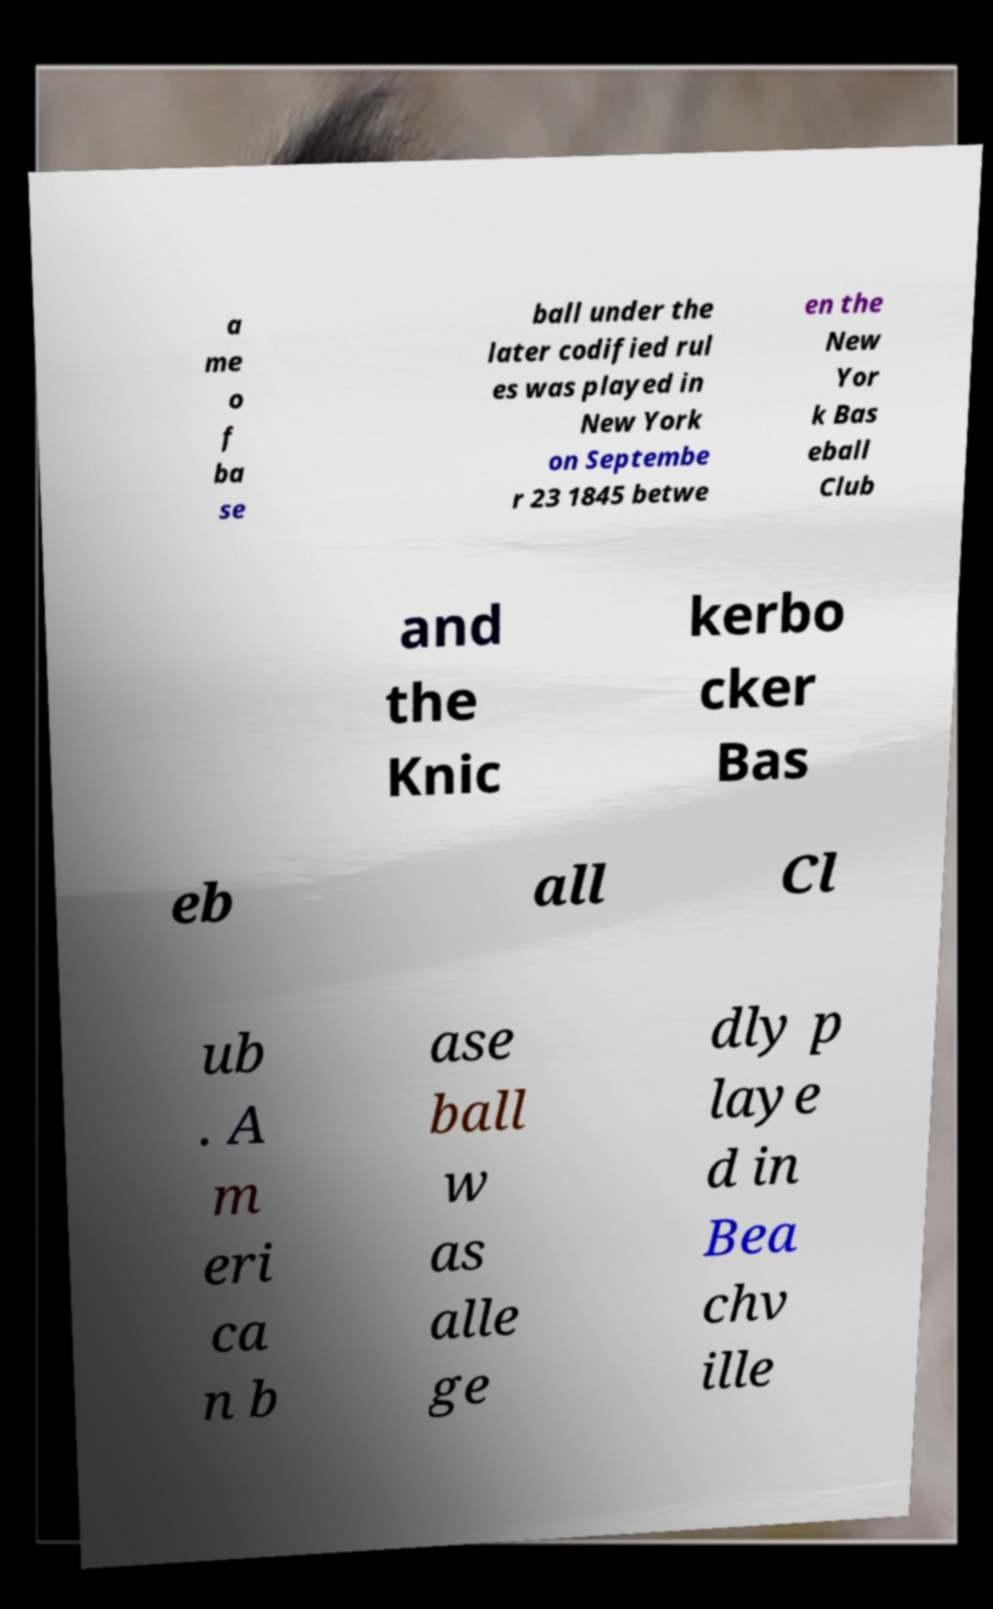Can you accurately transcribe the text from the provided image for me? a me o f ba se ball under the later codified rul es was played in New York on Septembe r 23 1845 betwe en the New Yor k Bas eball Club and the Knic kerbo cker Bas eb all Cl ub . A m eri ca n b ase ball w as alle ge dly p laye d in Bea chv ille 